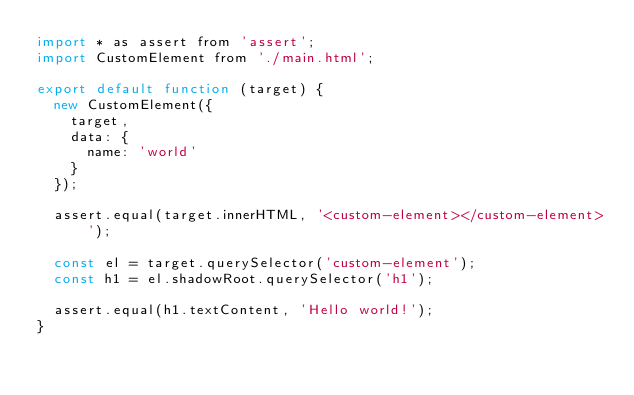Convert code to text. <code><loc_0><loc_0><loc_500><loc_500><_JavaScript_>import * as assert from 'assert';
import CustomElement from './main.html';

export default function (target) {
	new CustomElement({
		target,
		data: {
			name: 'world'
		}
	});

	assert.equal(target.innerHTML, '<custom-element></custom-element>');

	const el = target.querySelector('custom-element');
	const h1 = el.shadowRoot.querySelector('h1');

	assert.equal(h1.textContent, 'Hello world!');
}</code> 